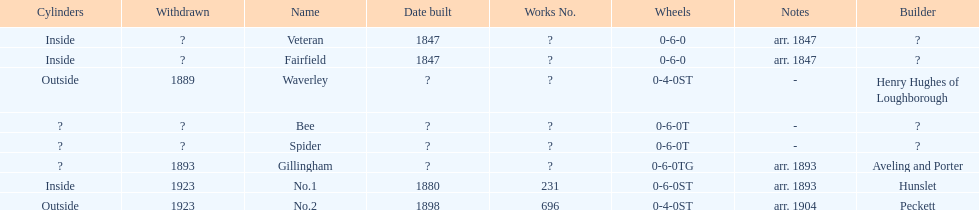How long after fairfield was no. 1 built? 33 years. 